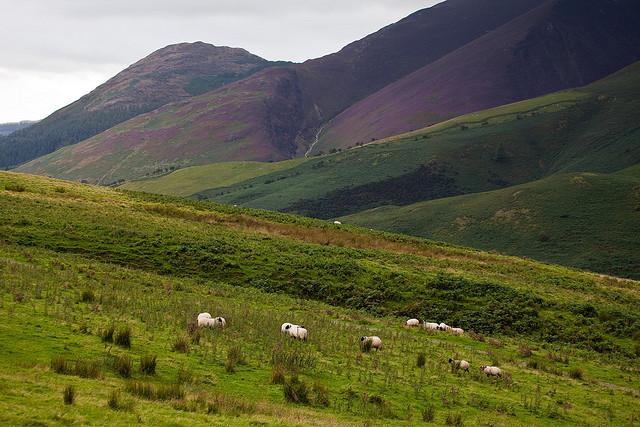Does it look like rain?
Short answer required. No. Is there water?
Answer briefly. No. What are the light objects on the ground?
Concise answer only. Sheep. What color are the animals?
Keep it brief. White. Is this in New Zealand?
Short answer required. Yes. Is this a zoo?
Concise answer only. No. What type of animal is this?
Write a very short answer. Sheep. Are the hills green?
Answer briefly. Yes. 